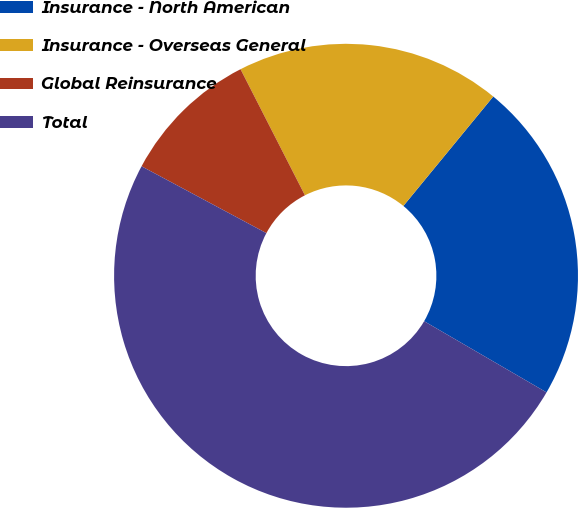Convert chart to OTSL. <chart><loc_0><loc_0><loc_500><loc_500><pie_chart><fcel>Insurance - North American<fcel>Insurance - Overseas General<fcel>Global Reinsurance<fcel>Total<nl><fcel>22.44%<fcel>18.46%<fcel>9.66%<fcel>49.44%<nl></chart> 